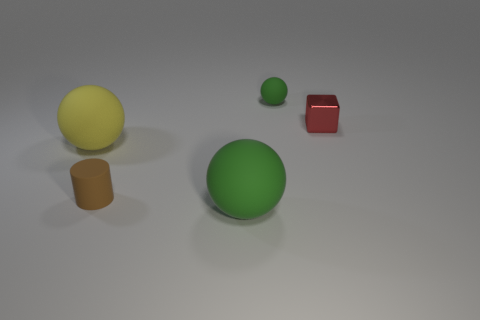Subtract all red cubes. How many green balls are left? 2 Subtract 1 balls. How many balls are left? 2 Subtract all small rubber spheres. How many spheres are left? 2 Add 1 big brown metal balls. How many objects exist? 6 Subtract all cubes. How many objects are left? 4 Add 4 small rubber cubes. How many small rubber cubes exist? 4 Subtract 0 cyan spheres. How many objects are left? 5 Subtract all green spheres. Subtract all small metal blocks. How many objects are left? 2 Add 1 tiny red shiny objects. How many tiny red shiny objects are left? 2 